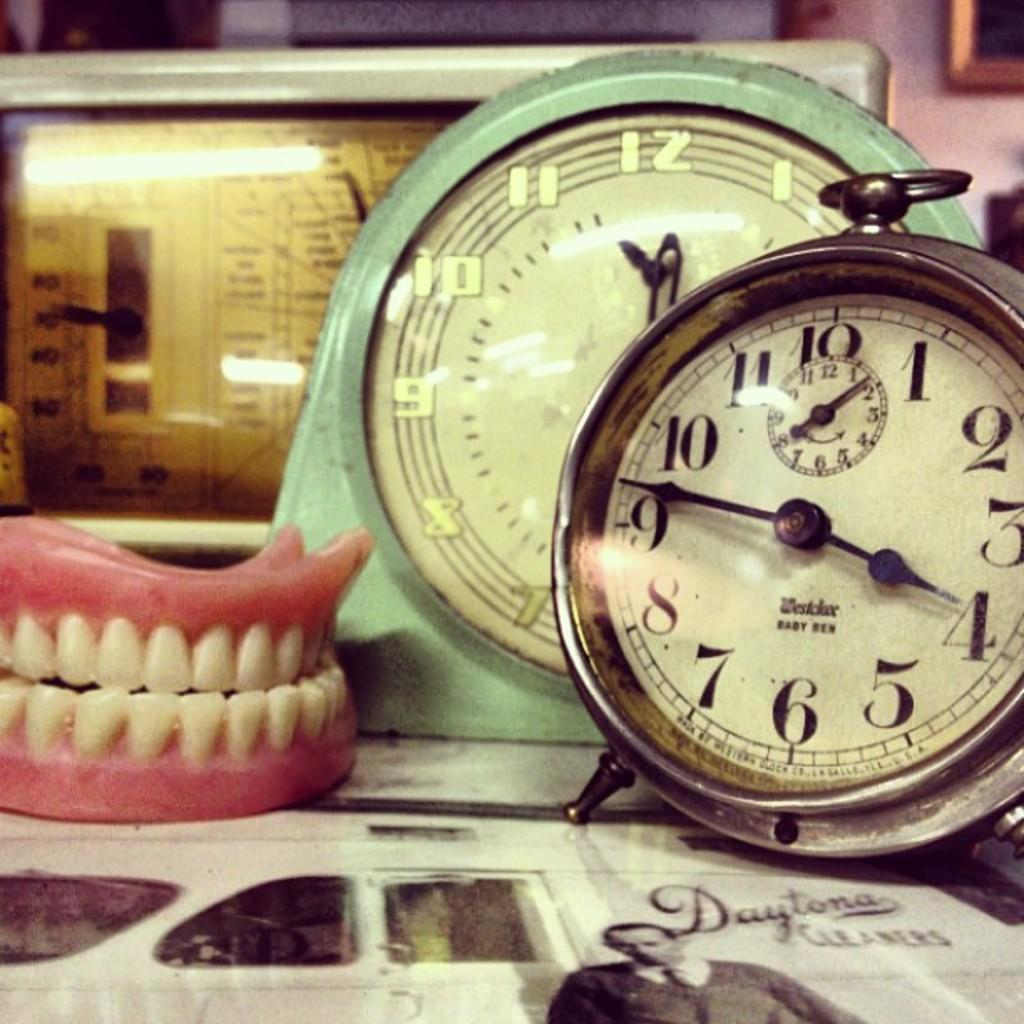<image>
Write a terse but informative summary of the picture. A clock on the right shows the time as 3:46. 